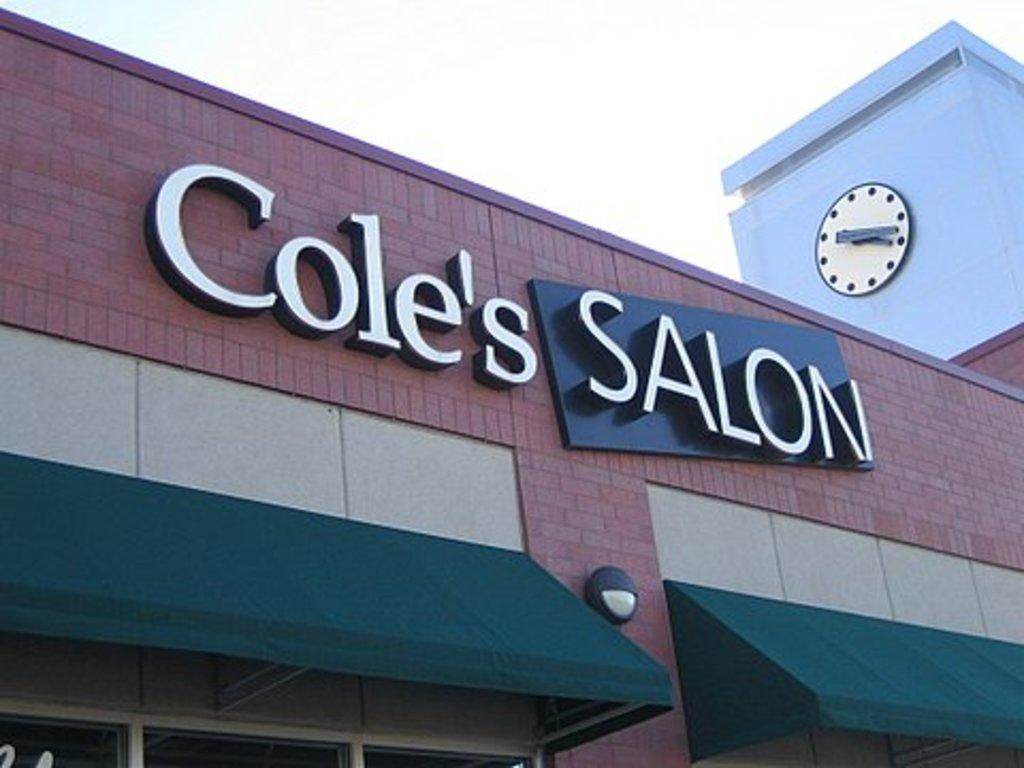<image>
Describe the image concisely. A salon with green overhangs and a sign that says Cole's Salon. 